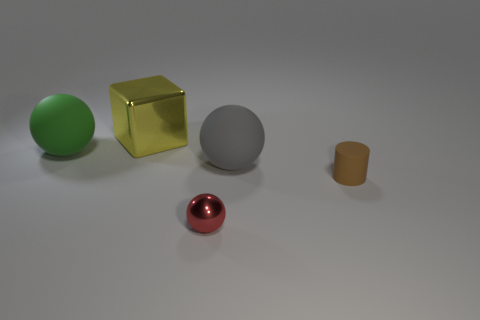Add 3 cylinders. How many objects exist? 8 Subtract all blocks. How many objects are left? 4 Subtract 0 yellow cylinders. How many objects are left? 5 Subtract all gray shiny balls. Subtract all big metal blocks. How many objects are left? 4 Add 4 large matte balls. How many large matte balls are left? 6 Add 2 small metal spheres. How many small metal spheres exist? 3 